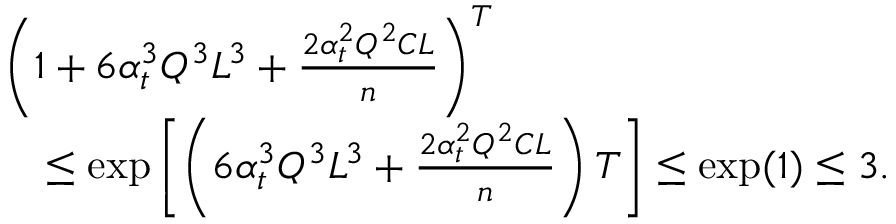Convert formula to latex. <formula><loc_0><loc_0><loc_500><loc_500>\begin{array} { r l } & { \left ( 1 + 6 \alpha _ { t } ^ { 3 } Q ^ { 3 } L ^ { 3 } + \frac { 2 \alpha _ { t } ^ { 2 } Q ^ { 2 } C L } { n } \right ) ^ { T } } \\ & { \quad \leq \exp \left [ \left ( 6 \alpha _ { t } ^ { 3 } Q ^ { 3 } L ^ { 3 } + \frac { 2 \alpha _ { t } ^ { 2 } Q ^ { 2 } C L } { n } \right ) T \right ] \leq \exp ( 1 ) \leq 3 . } \end{array}</formula> 